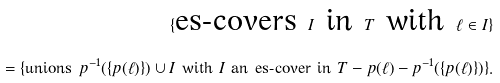Convert formula to latex. <formula><loc_0><loc_0><loc_500><loc_500>\{ \text {es-covers } I \text { in } T \text { with } \ell \in I \} \\ = \{ \text {unions } p ^ { - 1 } ( \{ p ( \ell ) \} ) \cup I \text { with } I \text { an es-cover in } T - p ( \ell ) - p ^ { - 1 } ( \{ p ( \ell ) \} ) \} .</formula> 